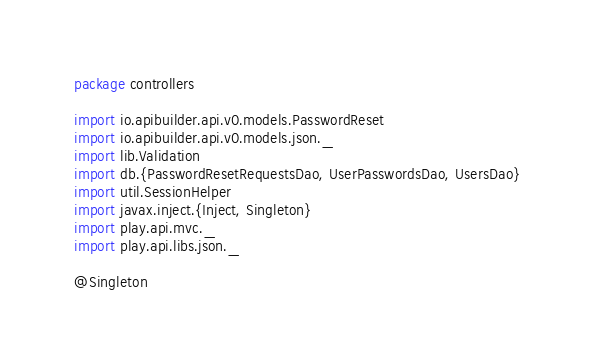Convert code to text. <code><loc_0><loc_0><loc_500><loc_500><_Scala_>package controllers

import io.apibuilder.api.v0.models.PasswordReset
import io.apibuilder.api.v0.models.json._
import lib.Validation
import db.{PasswordResetRequestsDao, UserPasswordsDao, UsersDao}
import util.SessionHelper
import javax.inject.{Inject, Singleton}
import play.api.mvc._
import play.api.libs.json._

@Singleton</code> 